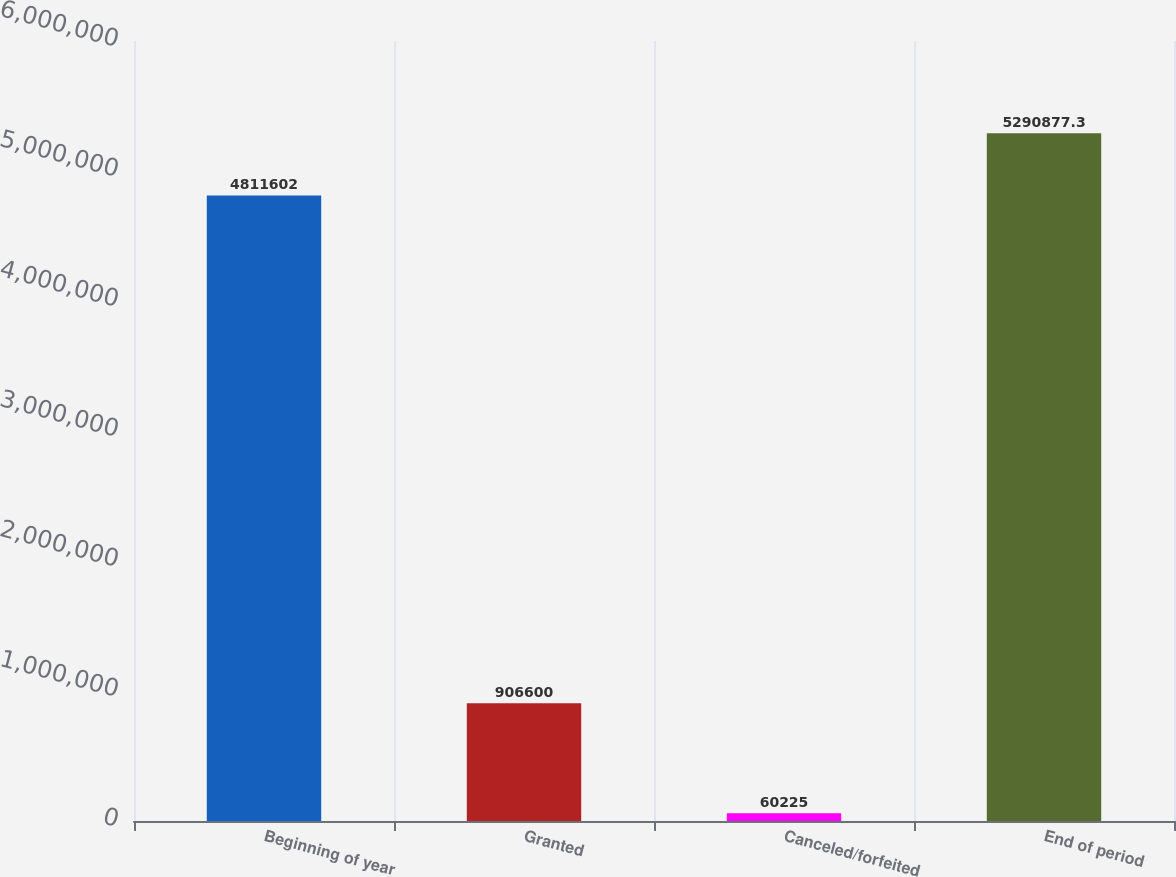Convert chart. <chart><loc_0><loc_0><loc_500><loc_500><bar_chart><fcel>Beginning of year<fcel>Granted<fcel>Canceled/forfeited<fcel>End of period<nl><fcel>4.8116e+06<fcel>906600<fcel>60225<fcel>5.29088e+06<nl></chart> 